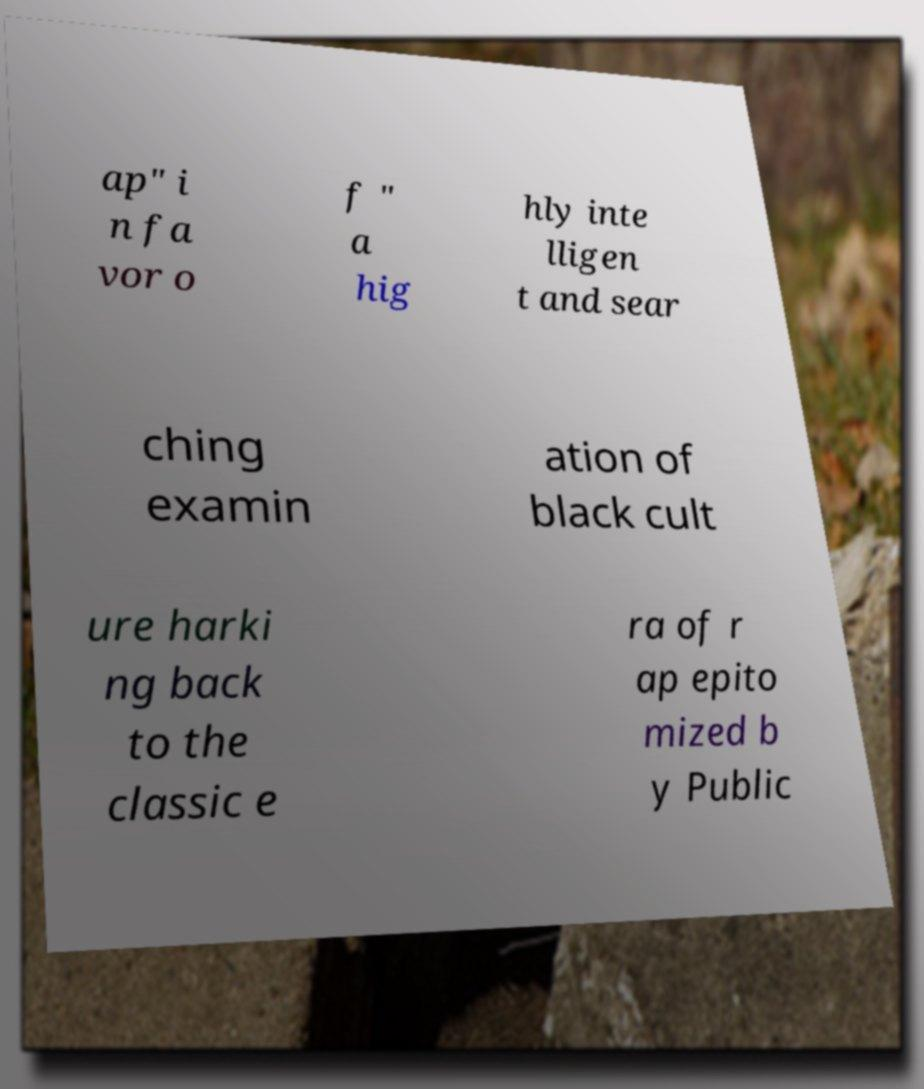Can you read and provide the text displayed in the image?This photo seems to have some interesting text. Can you extract and type it out for me? ap" i n fa vor o f " a hig hly inte lligen t and sear ching examin ation of black cult ure harki ng back to the classic e ra of r ap epito mized b y Public 